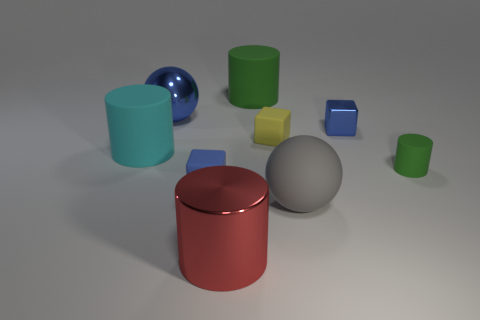What size is the other matte object that is the same shape as the yellow rubber thing?
Ensure brevity in your answer.  Small. What number of red objects are either large cylinders or small metallic cylinders?
Provide a succinct answer. 1. There is a ball that is right of the red metal cylinder; what number of gray things are behind it?
Your response must be concise. 0. What number of other objects are the same shape as the tiny blue metal thing?
Give a very brief answer. 2. What material is the ball that is the same color as the tiny metal cube?
Give a very brief answer. Metal. How many cubes have the same color as the big metal ball?
Provide a short and direct response. 2. What is the color of the tiny cylinder that is made of the same material as the tiny yellow thing?
Provide a succinct answer. Green. Is there a green rubber cylinder that has the same size as the metal block?
Provide a short and direct response. Yes. Is the number of tiny matte objects that are behind the large metallic cylinder greater than the number of gray things on the right side of the small blue rubber cube?
Ensure brevity in your answer.  Yes. Is the material of the big gray object that is in front of the big green cylinder the same as the tiny blue block that is in front of the yellow thing?
Provide a short and direct response. Yes. 